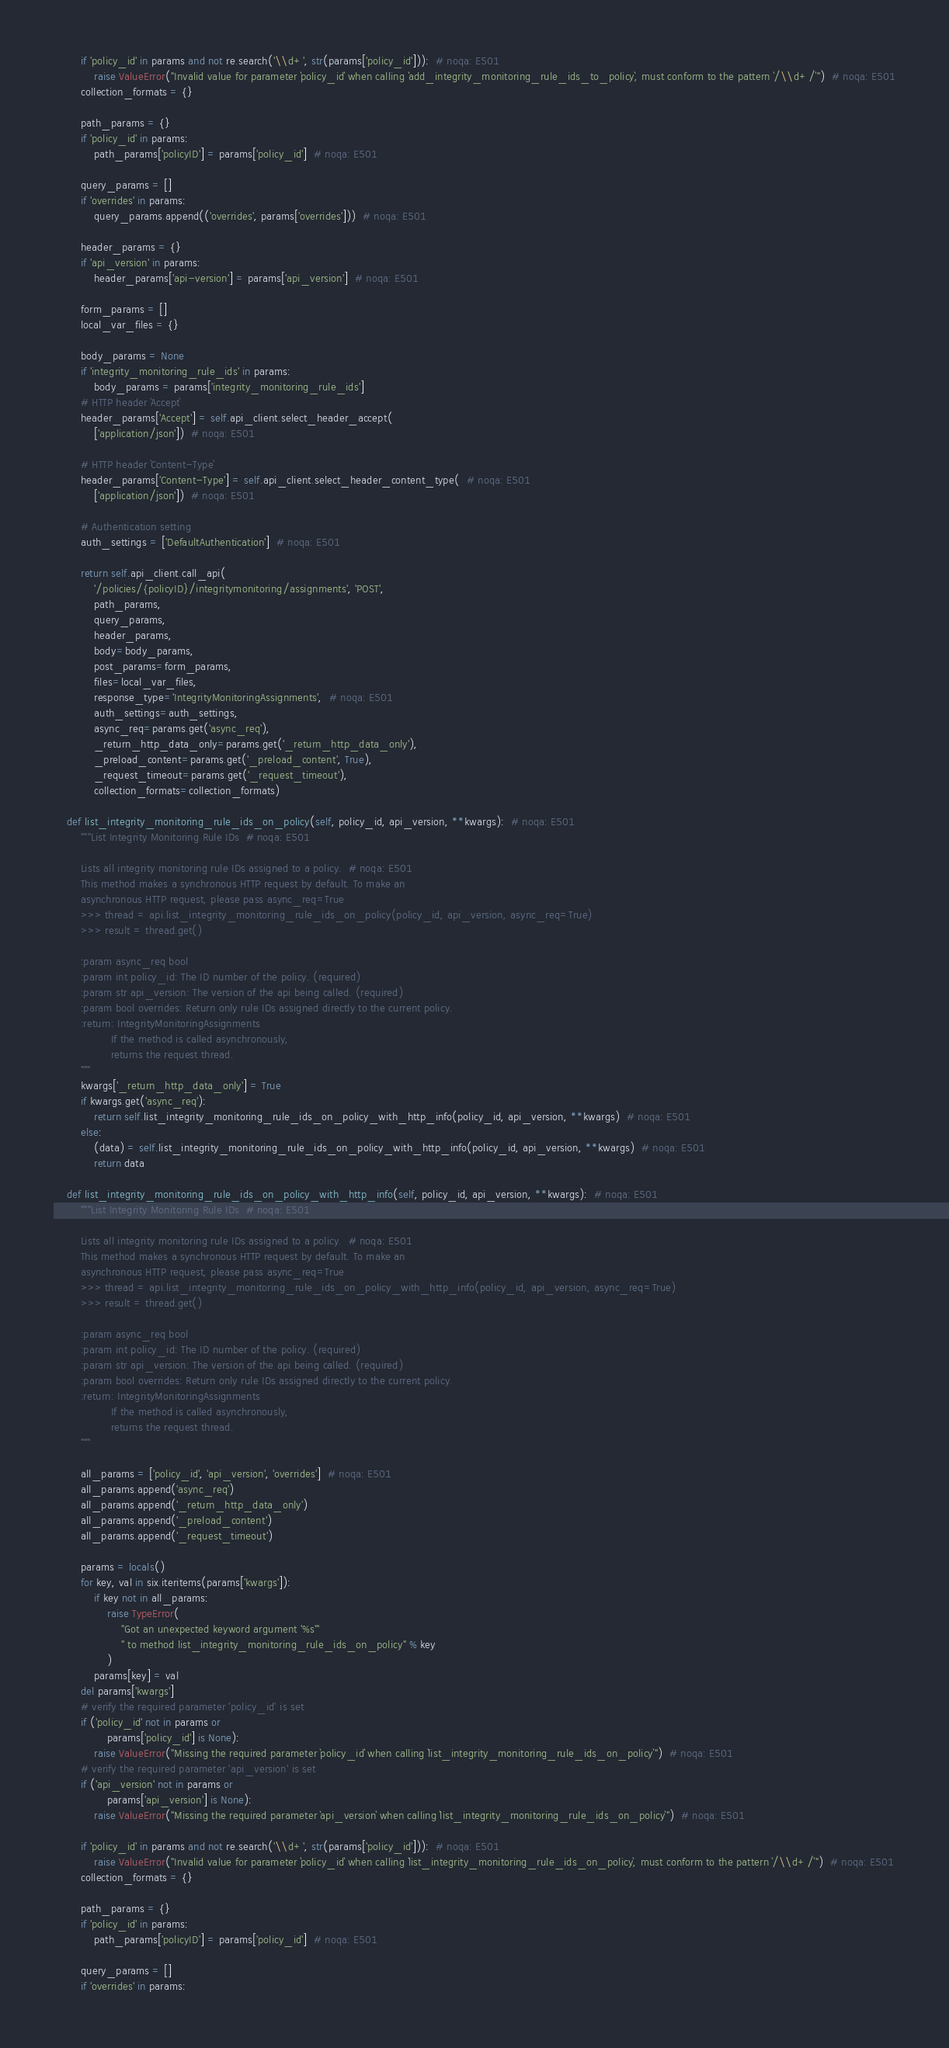Convert code to text. <code><loc_0><loc_0><loc_500><loc_500><_Python_>
        if 'policy_id' in params and not re.search('\\d+', str(params['policy_id'])):  # noqa: E501
            raise ValueError("Invalid value for parameter `policy_id` when calling `add_integrity_monitoring_rule_ids_to_policy`, must conform to the pattern `/\\d+/`")  # noqa: E501
        collection_formats = {}

        path_params = {}
        if 'policy_id' in params:
            path_params['policyID'] = params['policy_id']  # noqa: E501

        query_params = []
        if 'overrides' in params:
            query_params.append(('overrides', params['overrides']))  # noqa: E501

        header_params = {}
        if 'api_version' in params:
            header_params['api-version'] = params['api_version']  # noqa: E501

        form_params = []
        local_var_files = {}

        body_params = None
        if 'integrity_monitoring_rule_ids' in params:
            body_params = params['integrity_monitoring_rule_ids']
        # HTTP header `Accept`
        header_params['Accept'] = self.api_client.select_header_accept(
            ['application/json'])  # noqa: E501

        # HTTP header `Content-Type`
        header_params['Content-Type'] = self.api_client.select_header_content_type(  # noqa: E501
            ['application/json'])  # noqa: E501

        # Authentication setting
        auth_settings = ['DefaultAuthentication']  # noqa: E501

        return self.api_client.call_api(
            '/policies/{policyID}/integritymonitoring/assignments', 'POST',
            path_params,
            query_params,
            header_params,
            body=body_params,
            post_params=form_params,
            files=local_var_files,
            response_type='IntegrityMonitoringAssignments',  # noqa: E501
            auth_settings=auth_settings,
            async_req=params.get('async_req'),
            _return_http_data_only=params.get('_return_http_data_only'),
            _preload_content=params.get('_preload_content', True),
            _request_timeout=params.get('_request_timeout'),
            collection_formats=collection_formats)

    def list_integrity_monitoring_rule_ids_on_policy(self, policy_id, api_version, **kwargs):  # noqa: E501
        """List Integrity Monitoring Rule IDs  # noqa: E501

        Lists all integrity monitoring rule IDs assigned to a policy.  # noqa: E501
        This method makes a synchronous HTTP request by default. To make an
        asynchronous HTTP request, please pass async_req=True
        >>> thread = api.list_integrity_monitoring_rule_ids_on_policy(policy_id, api_version, async_req=True)
        >>> result = thread.get()

        :param async_req bool
        :param int policy_id: The ID number of the policy. (required)
        :param str api_version: The version of the api being called. (required)
        :param bool overrides: Return only rule IDs assigned directly to the current policy.
        :return: IntegrityMonitoringAssignments
                 If the method is called asynchronously,
                 returns the request thread.
        """
        kwargs['_return_http_data_only'] = True
        if kwargs.get('async_req'):
            return self.list_integrity_monitoring_rule_ids_on_policy_with_http_info(policy_id, api_version, **kwargs)  # noqa: E501
        else:
            (data) = self.list_integrity_monitoring_rule_ids_on_policy_with_http_info(policy_id, api_version, **kwargs)  # noqa: E501
            return data

    def list_integrity_monitoring_rule_ids_on_policy_with_http_info(self, policy_id, api_version, **kwargs):  # noqa: E501
        """List Integrity Monitoring Rule IDs  # noqa: E501

        Lists all integrity monitoring rule IDs assigned to a policy.  # noqa: E501
        This method makes a synchronous HTTP request by default. To make an
        asynchronous HTTP request, please pass async_req=True
        >>> thread = api.list_integrity_monitoring_rule_ids_on_policy_with_http_info(policy_id, api_version, async_req=True)
        >>> result = thread.get()

        :param async_req bool
        :param int policy_id: The ID number of the policy. (required)
        :param str api_version: The version of the api being called. (required)
        :param bool overrides: Return only rule IDs assigned directly to the current policy.
        :return: IntegrityMonitoringAssignments
                 If the method is called asynchronously,
                 returns the request thread.
        """

        all_params = ['policy_id', 'api_version', 'overrides']  # noqa: E501
        all_params.append('async_req')
        all_params.append('_return_http_data_only')
        all_params.append('_preload_content')
        all_params.append('_request_timeout')

        params = locals()
        for key, val in six.iteritems(params['kwargs']):
            if key not in all_params:
                raise TypeError(
                    "Got an unexpected keyword argument '%s'"
                    " to method list_integrity_monitoring_rule_ids_on_policy" % key
                )
            params[key] = val
        del params['kwargs']
        # verify the required parameter 'policy_id' is set
        if ('policy_id' not in params or
                params['policy_id'] is None):
            raise ValueError("Missing the required parameter `policy_id` when calling `list_integrity_monitoring_rule_ids_on_policy`")  # noqa: E501
        # verify the required parameter 'api_version' is set
        if ('api_version' not in params or
                params['api_version'] is None):
            raise ValueError("Missing the required parameter `api_version` when calling `list_integrity_monitoring_rule_ids_on_policy`")  # noqa: E501

        if 'policy_id' in params and not re.search('\\d+', str(params['policy_id'])):  # noqa: E501
            raise ValueError("Invalid value for parameter `policy_id` when calling `list_integrity_monitoring_rule_ids_on_policy`, must conform to the pattern `/\\d+/`")  # noqa: E501
        collection_formats = {}

        path_params = {}
        if 'policy_id' in params:
            path_params['policyID'] = params['policy_id']  # noqa: E501

        query_params = []
        if 'overrides' in params:</code> 